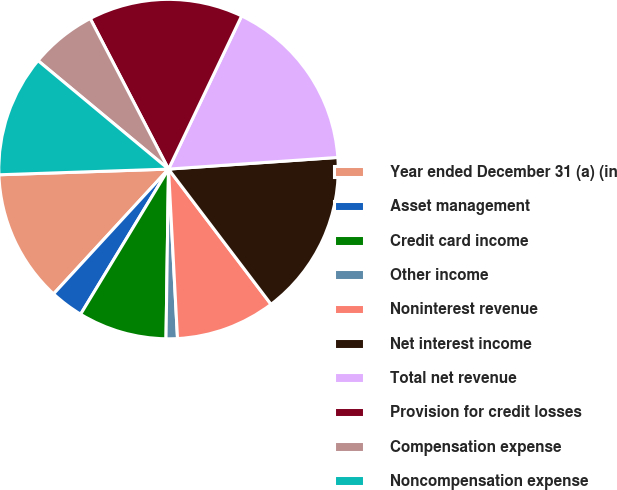<chart> <loc_0><loc_0><loc_500><loc_500><pie_chart><fcel>Year ended December 31 (a) (in<fcel>Asset management<fcel>Credit card income<fcel>Other income<fcel>Noninterest revenue<fcel>Net interest income<fcel>Total net revenue<fcel>Provision for credit losses<fcel>Compensation expense<fcel>Noncompensation expense<nl><fcel>12.62%<fcel>3.18%<fcel>8.43%<fcel>1.08%<fcel>9.48%<fcel>15.77%<fcel>16.82%<fcel>14.72%<fcel>6.33%<fcel>11.57%<nl></chart> 